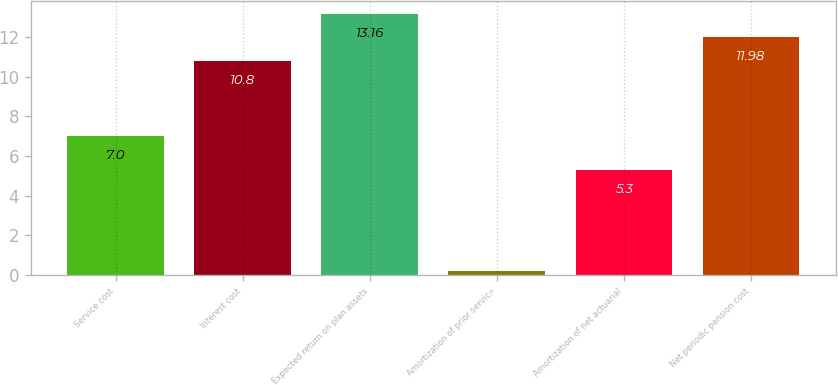Convert chart. <chart><loc_0><loc_0><loc_500><loc_500><bar_chart><fcel>Service cost<fcel>Interest cost<fcel>Expected return on plan assets<fcel>Amortization of prior service<fcel>Amortization of net actuarial<fcel>Net periodic pension cost<nl><fcel>7<fcel>10.8<fcel>13.16<fcel>0.2<fcel>5.3<fcel>11.98<nl></chart> 